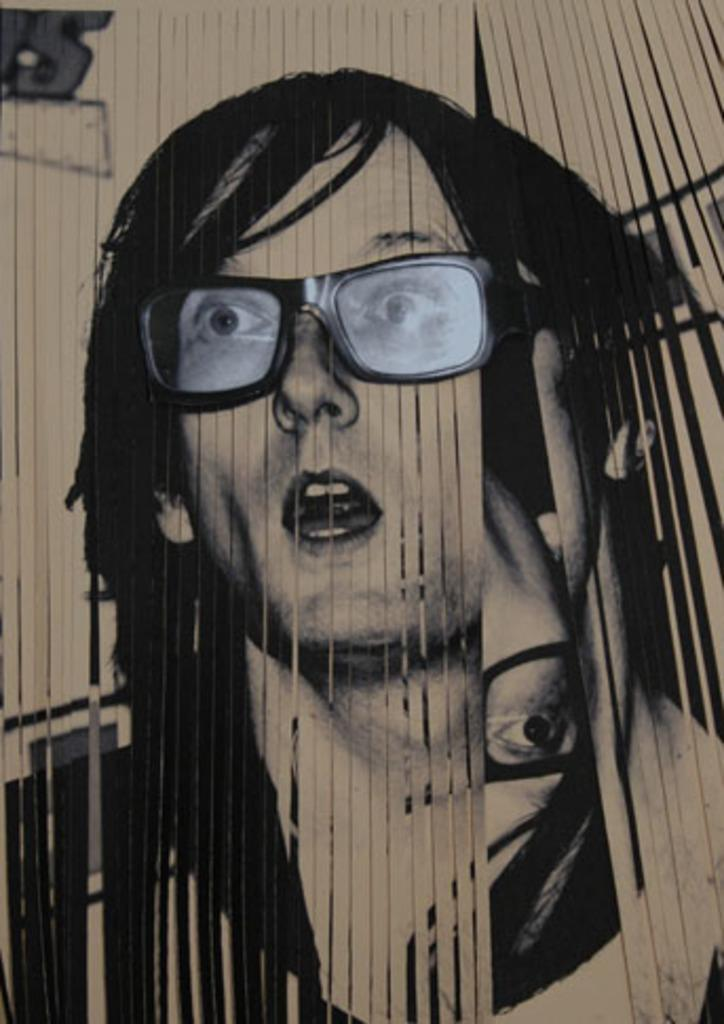What is there is a white object in the image, what is it? There is a white color object in the image, and it appears to be a vertical window blind. What can be seen on the window blinds? There are pictures of persons on the window blinds. Can you see any caves or knots in the image? No, there are no caves or knots present in the image. Are there any bubbles visible in the image? No, there are no bubbles visible in the image. 